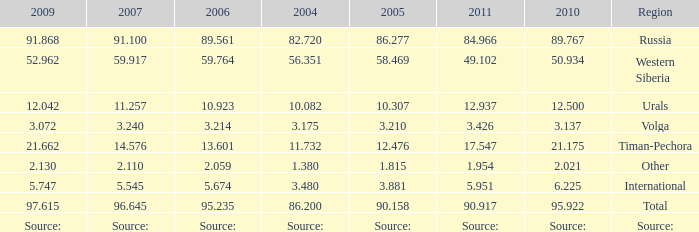What is the 2005 Lukoil oil prodroduction when in 2007 oil production 91.100 million tonnes? 86.277. 